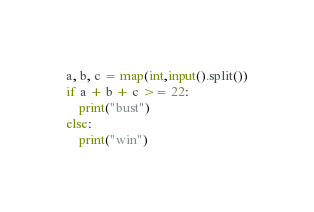<code> <loc_0><loc_0><loc_500><loc_500><_Python_>a, b, c = map(int,input().split())
if a + b + c >= 22:
    print("bust") 
else:
    print("win")</code> 